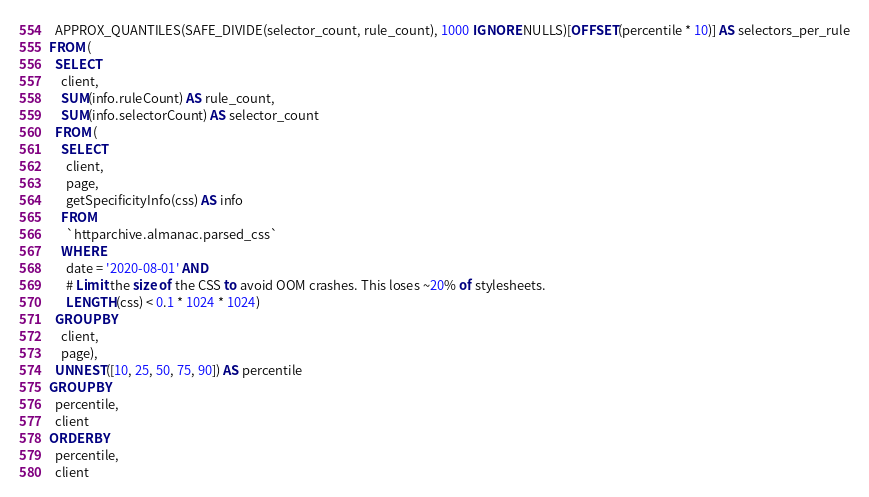<code> <loc_0><loc_0><loc_500><loc_500><_SQL_>  APPROX_QUANTILES(SAFE_DIVIDE(selector_count, rule_count), 1000 IGNORE NULLS)[OFFSET(percentile * 10)] AS selectors_per_rule
FROM (
  SELECT
    client,
    SUM(info.ruleCount) AS rule_count,
    SUM(info.selectorCount) AS selector_count
  FROM (
    SELECT
      client,
      page,
      getSpecificityInfo(css) AS info
    FROM
      `httparchive.almanac.parsed_css`
    WHERE
      date = '2020-08-01' AND
      # Limit the size of the CSS to avoid OOM crashes. This loses ~20% of stylesheets.
      LENGTH(css) < 0.1 * 1024 * 1024)
  GROUP BY
    client,
    page),
  UNNEST([10, 25, 50, 75, 90]) AS percentile
GROUP BY
  percentile,
  client
ORDER BY
  percentile,
  client
</code> 